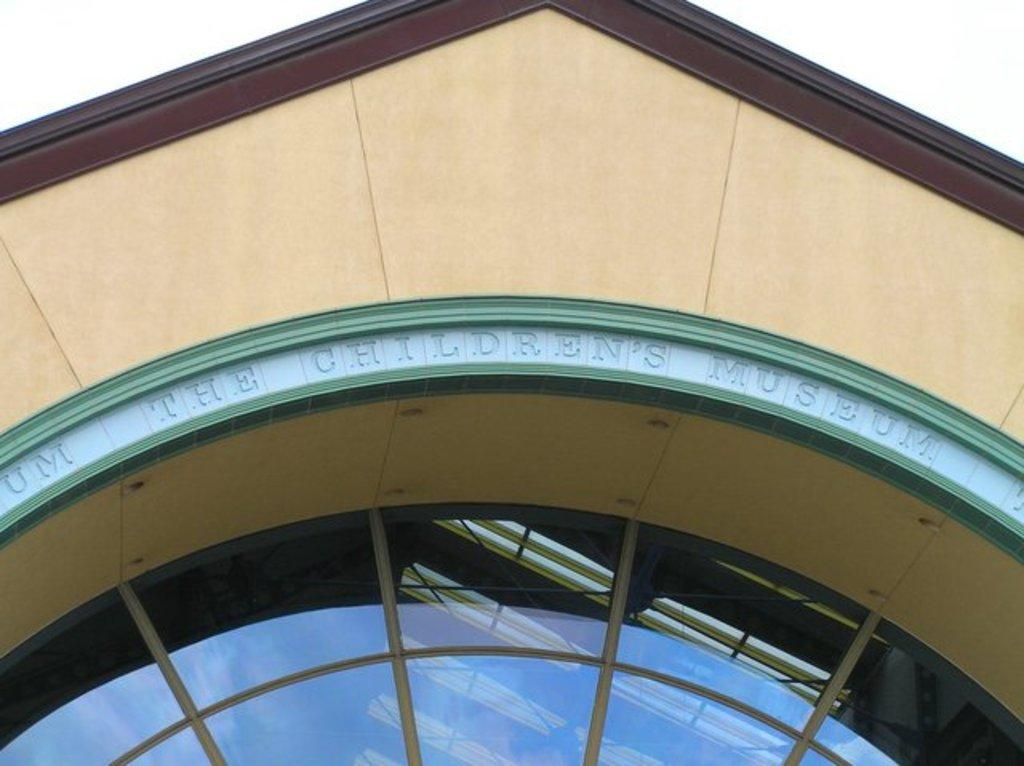What type of structure is present in the image? There is a building in the image. Can you describe any specific features of the building? The building has a window in the middle. What can be seen above the building in the image? The sky is visible above the building. What hobbies does the person in the window enjoy? There is no person present in the window in the image, so it is not possible to determine their hobbies. 